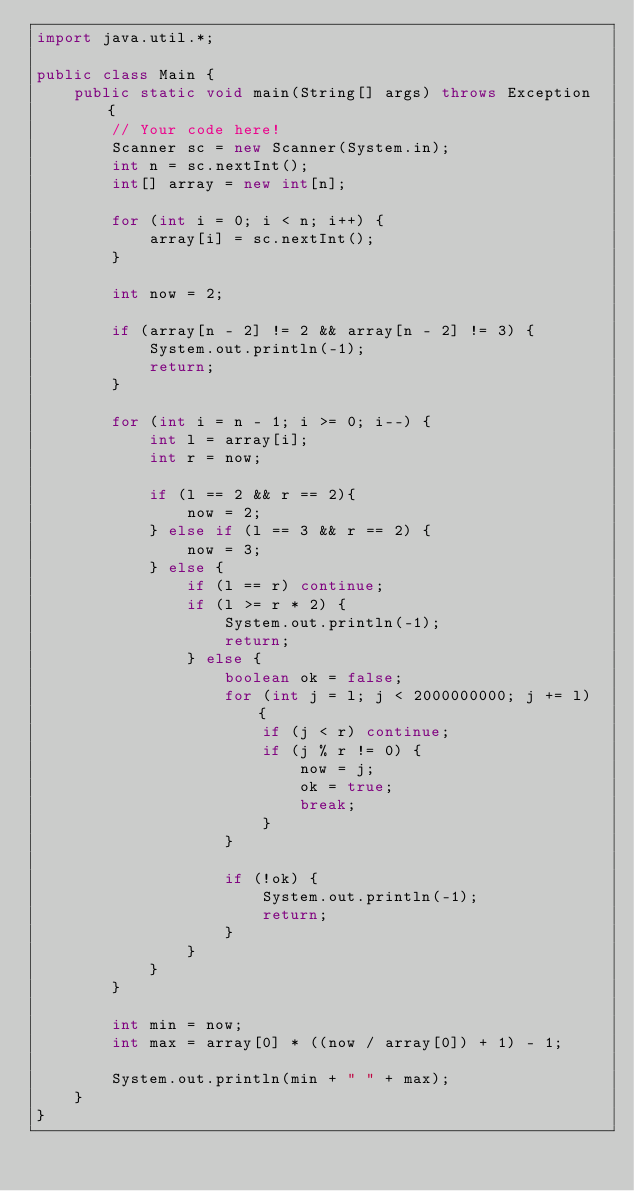Convert code to text. <code><loc_0><loc_0><loc_500><loc_500><_Java_>import java.util.*;

public class Main {
    public static void main(String[] args) throws Exception {
        // Your code here!
        Scanner sc = new Scanner(System.in);
        int n = sc.nextInt();
        int[] array = new int[n];
        
        for (int i = 0; i < n; i++) {
            array[i] = sc.nextInt();
        }
        
        int now = 2;
        
        if (array[n - 2] != 2 && array[n - 2] != 3) {
            System.out.println(-1);
            return;
        }
        
        for (int i = n - 1; i >= 0; i--) {
            int l = array[i];
            int r = now;
            
            if (l == 2 && r == 2){
                now = 2;
            } else if (l == 3 && r == 2) {
                now = 3;
            } else {
                if (l == r) continue;
                if (l >= r * 2) {
                    System.out.println(-1);
                    return;
                } else {
                    boolean ok = false;
                    for (int j = l; j < 2000000000; j += l) {
                        if (j < r) continue;
                        if (j % r != 0) {
                            now = j;
                            ok = true;
                            break;
                        }
                    }
                    
                    if (!ok) {
                        System.out.println(-1);
                        return;
                    }
                }
            }
        }
        
        int min = now;
        int max = array[0] * ((now / array[0]) + 1) - 1;
        
        System.out.println(min + " " + max);
    }
}
</code> 